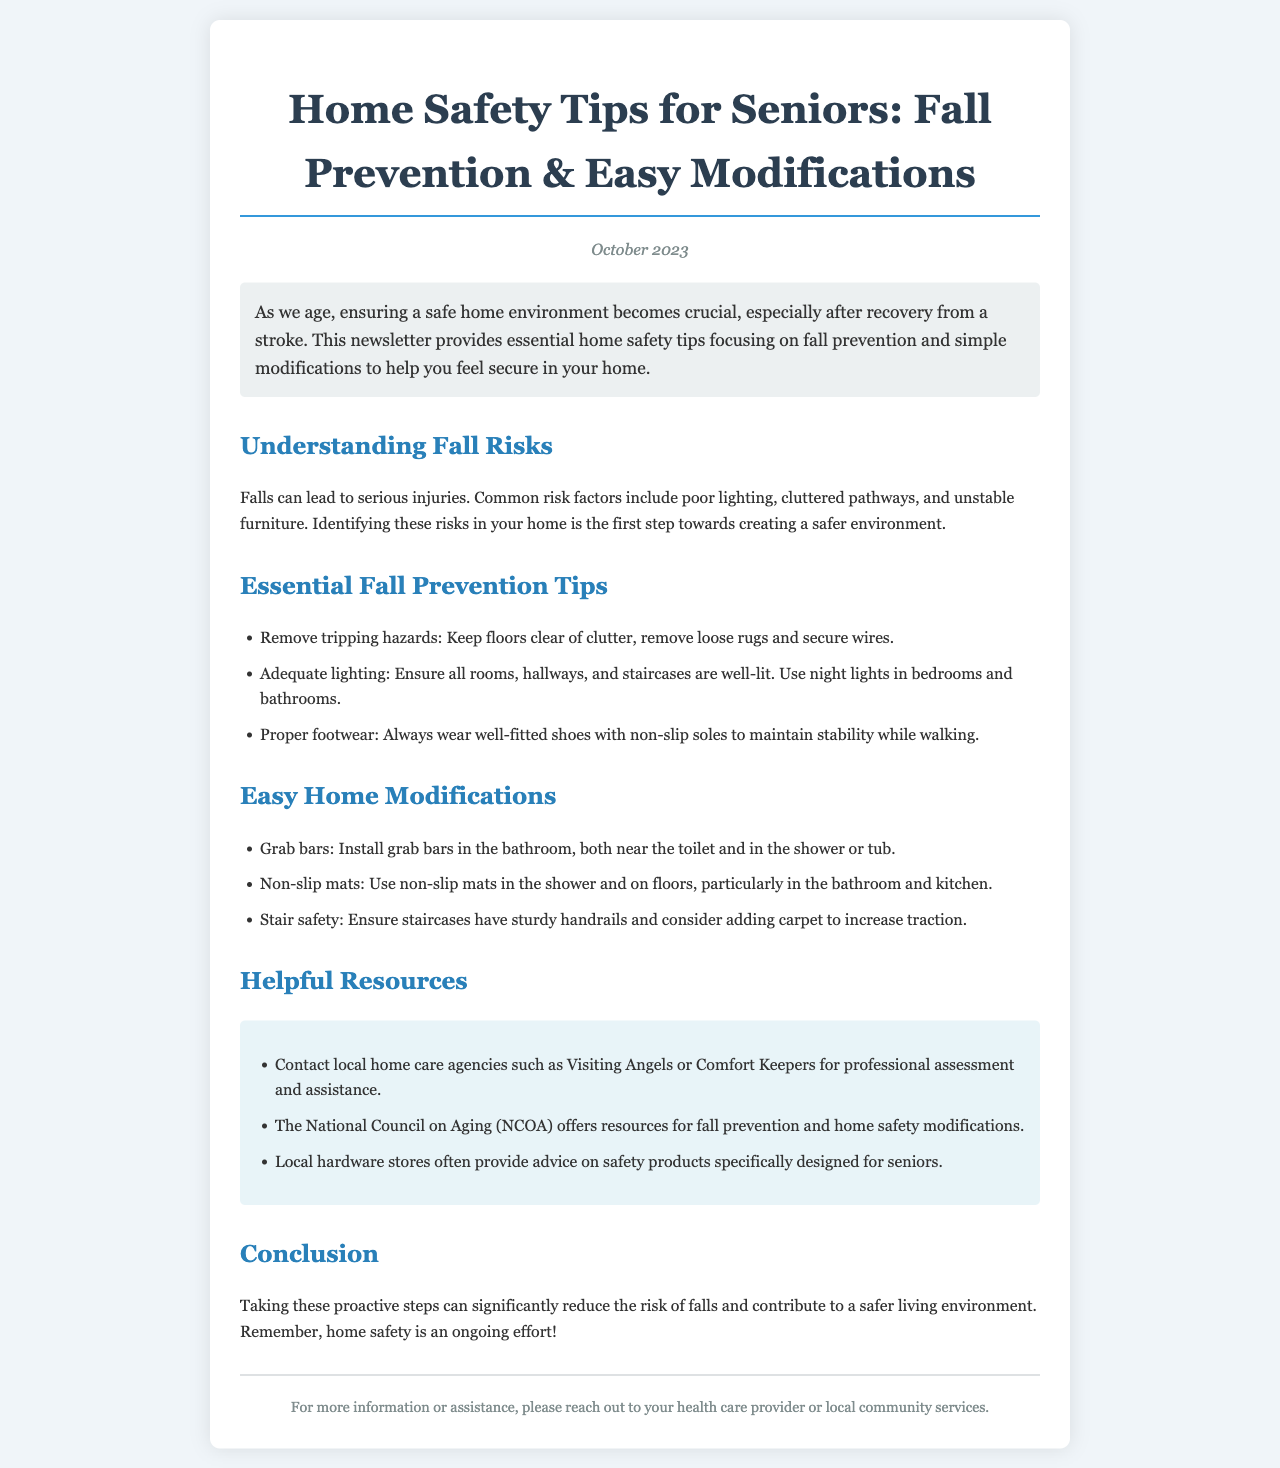What is the title of the newsletter? The title of the newsletter is specified at the top of the document, summarizing its main topic.
Answer: Home Safety Tips for Seniors: Fall Prevention & Easy Modifications What is the publication date? The publication date is mentioned below the title, indicating when the newsletter was released.
Answer: October 2023 What should be removed to prevent falls? This information is found in the list of fall prevention tips, highlighting specific actions to take in the home.
Answer: Tripping hazards Where should grab bars be installed? This information can be found in the easy home modifications section, detailing specific locations for installation for safety.
Answer: Bathroom What does the National Council on Aging offer? This is found in the resources section, indicating what assistance or information is available through this organization.
Answer: Resources for fall prevention What is a recommended feature for lighting? The document lists features that contribute to safety, specifically related to lighting improvements.
Answer: Adequate lighting How many safety tips are listed under fall prevention? This can be found by counting the items in the fall prevention tips section of the newsletter.
Answer: Three What type of footwear is recommended? This information emphasizes the importance of proper footwear to maintain stability while walking, which is mentioned in the fall prevention tips.
Answer: Well-fitted shoes What type of agency can be contacted for assistance? The resources section lists specific types of agencies that seniors can reach out to for advice and assistance.
Answer: Home care agencies 